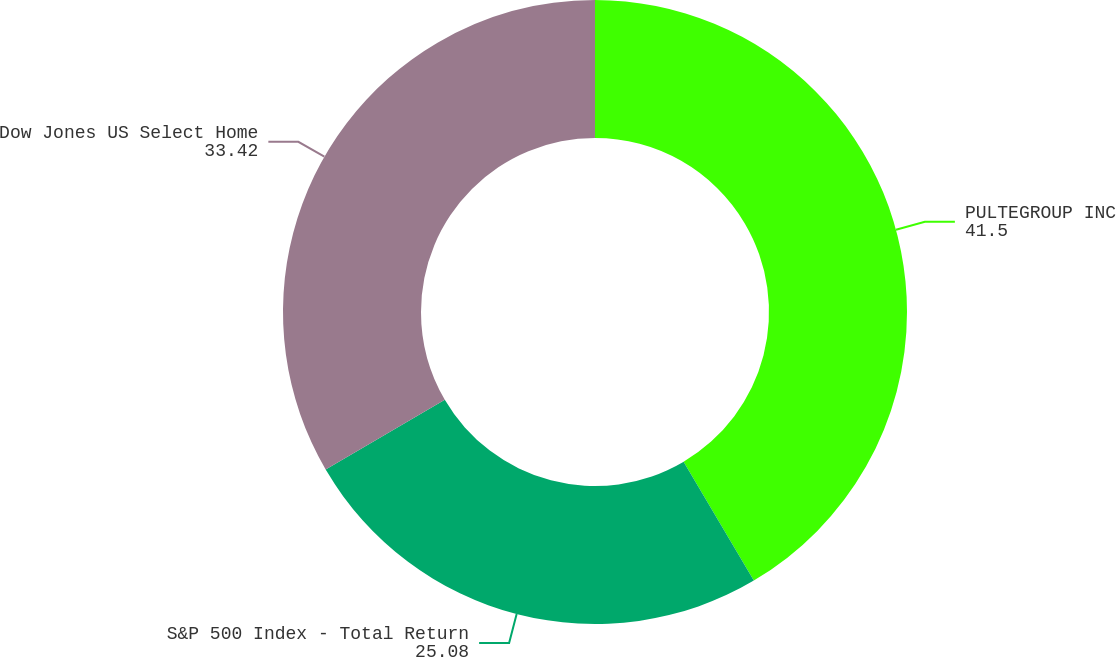Convert chart to OTSL. <chart><loc_0><loc_0><loc_500><loc_500><pie_chart><fcel>PULTEGROUP INC<fcel>S&P 500 Index - Total Return<fcel>Dow Jones US Select Home<nl><fcel>41.5%<fcel>25.08%<fcel>33.42%<nl></chart> 